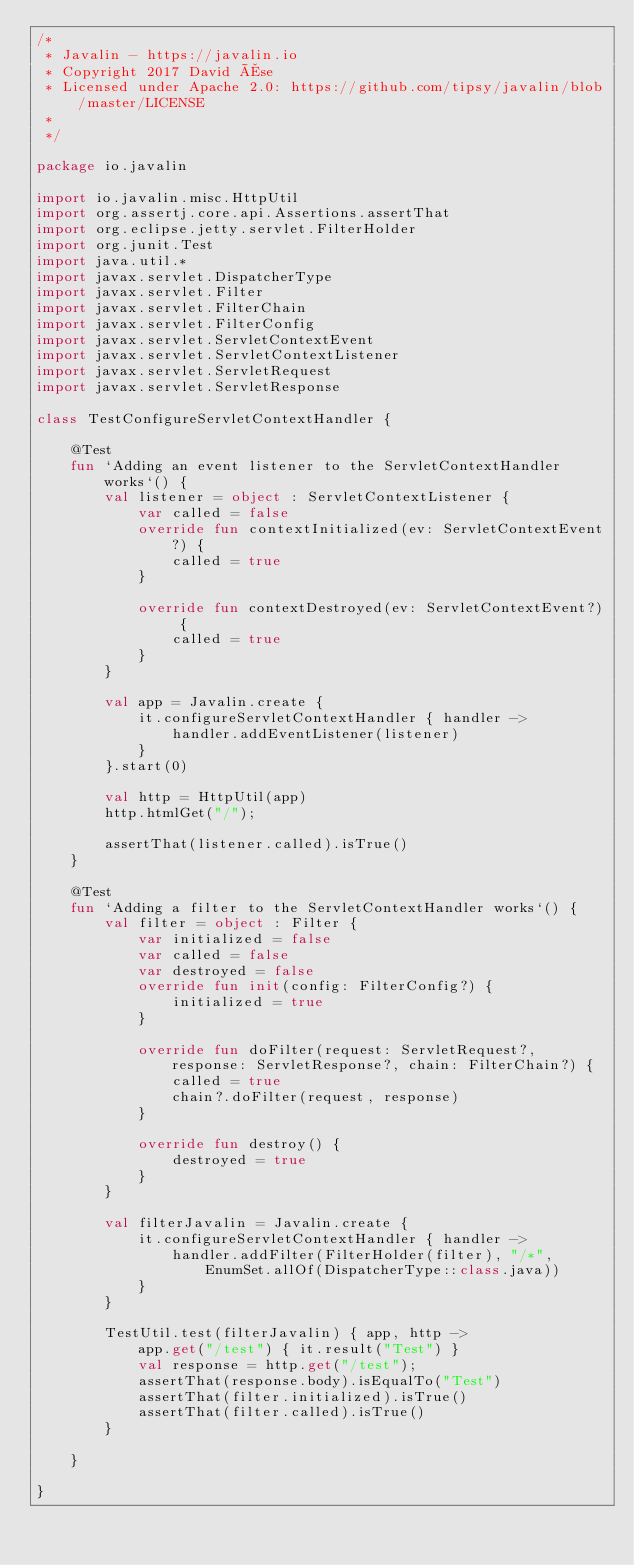<code> <loc_0><loc_0><loc_500><loc_500><_Kotlin_>/*
 * Javalin - https://javalin.io
 * Copyright 2017 David Åse
 * Licensed under Apache 2.0: https://github.com/tipsy/javalin/blob/master/LICENSE
 *
 */

package io.javalin

import io.javalin.misc.HttpUtil
import org.assertj.core.api.Assertions.assertThat
import org.eclipse.jetty.servlet.FilterHolder
import org.junit.Test
import java.util.*
import javax.servlet.DispatcherType
import javax.servlet.Filter
import javax.servlet.FilterChain
import javax.servlet.FilterConfig
import javax.servlet.ServletContextEvent
import javax.servlet.ServletContextListener
import javax.servlet.ServletRequest
import javax.servlet.ServletResponse

class TestConfigureServletContextHandler {

    @Test
    fun `Adding an event listener to the ServletContextHandler works`() {
        val listener = object : ServletContextListener {
            var called = false
            override fun contextInitialized(ev: ServletContextEvent?) {
                called = true
            }

            override fun contextDestroyed(ev: ServletContextEvent?) {
                called = true
            }
        }

        val app = Javalin.create {
            it.configureServletContextHandler { handler ->
                handler.addEventListener(listener)
            }
        }.start(0)

        val http = HttpUtil(app)
        http.htmlGet("/");

        assertThat(listener.called).isTrue()
    }

    @Test
    fun `Adding a filter to the ServletContextHandler works`() {
        val filter = object : Filter {
            var initialized = false
            var called = false
            var destroyed = false
            override fun init(config: FilterConfig?) {
                initialized = true
            }

            override fun doFilter(request: ServletRequest?, response: ServletResponse?, chain: FilterChain?) {
                called = true
                chain?.doFilter(request, response)
            }

            override fun destroy() {
                destroyed = true
            }
        }

        val filterJavalin = Javalin.create {
            it.configureServletContextHandler { handler ->
                handler.addFilter(FilterHolder(filter), "/*", EnumSet.allOf(DispatcherType::class.java))
            }
        }

        TestUtil.test(filterJavalin) { app, http ->
            app.get("/test") { it.result("Test") }
            val response = http.get("/test");
            assertThat(response.body).isEqualTo("Test")
            assertThat(filter.initialized).isTrue()
            assertThat(filter.called).isTrue()
        }

    }

}
</code> 